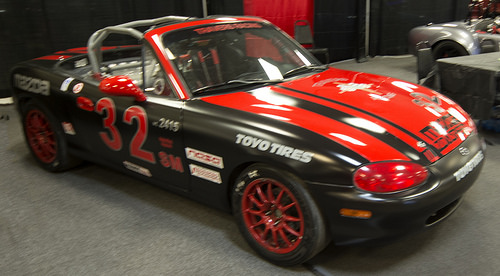<image>
Is the glass in the glass? No. The glass is not contained within the glass. These objects have a different spatial relationship. 